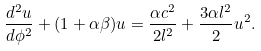Convert formula to latex. <formula><loc_0><loc_0><loc_500><loc_500>\frac { d ^ { 2 } u } { d \phi ^ { 2 } } + ( 1 + \alpha \beta ) u = \frac { \alpha c ^ { 2 } } { 2 l ^ { 2 } } + \frac { 3 \alpha l ^ { 2 } } { 2 } u ^ { 2 } .</formula> 